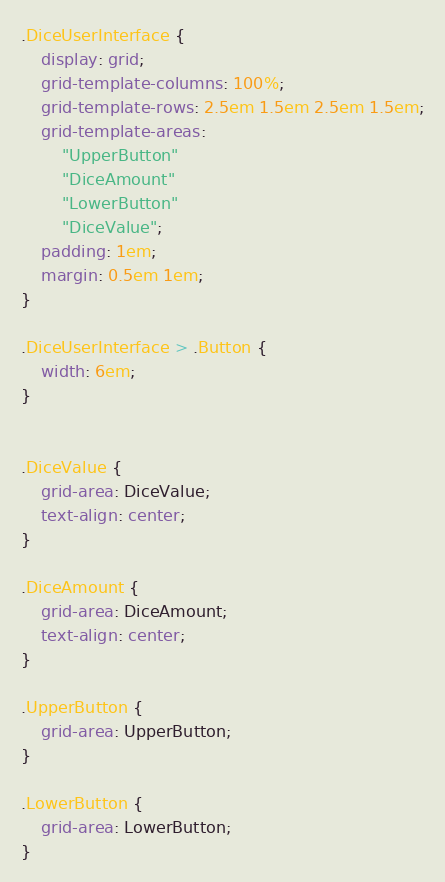Convert code to text. <code><loc_0><loc_0><loc_500><loc_500><_CSS_>.DiceUserInterface {
    display: grid;
    grid-template-columns: 100%;
    grid-template-rows: 2.5em 1.5em 2.5em 1.5em;
    grid-template-areas: 
        "UpperButton"
        "DiceAmount"
        "LowerButton"
        "DiceValue";
    padding: 1em;
    margin: 0.5em 1em;
}

.DiceUserInterface > .Button {
    width: 6em;
}


.DiceValue {
    grid-area: DiceValue;
    text-align: center;
}

.DiceAmount {
    grid-area: DiceAmount;
    text-align: center;
}

.UpperButton {
    grid-area: UpperButton;
}

.LowerButton {
    grid-area: LowerButton;
}</code> 